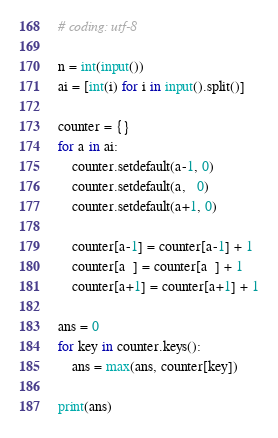Convert code to text. <code><loc_0><loc_0><loc_500><loc_500><_Python_># coding: utf-8

n = int(input())
ai = [int(i) for i in input().split()]

counter = {}
for a in ai:
    counter.setdefault(a-1, 0)
    counter.setdefault(a,   0)
    counter.setdefault(a+1, 0)
    
    counter[a-1] = counter[a-1] + 1
    counter[a  ] = counter[a  ] + 1
    counter[a+1] = counter[a+1] + 1

ans = 0
for key in counter.keys():
    ans = max(ans, counter[key])

print(ans)
</code> 